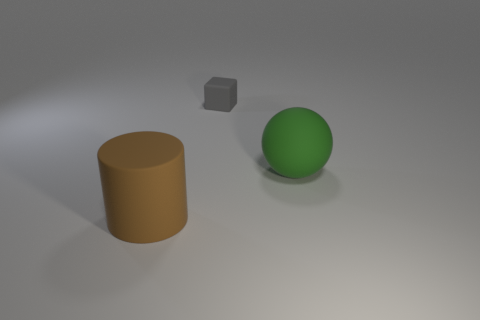Add 1 big balls. How many objects exist? 4 Subtract all blocks. How many objects are left? 2 Subtract all gray cubes. Subtract all tiny gray matte cylinders. How many objects are left? 2 Add 1 large green matte spheres. How many large green matte spheres are left? 2 Add 2 gray blocks. How many gray blocks exist? 3 Subtract 0 blue spheres. How many objects are left? 3 